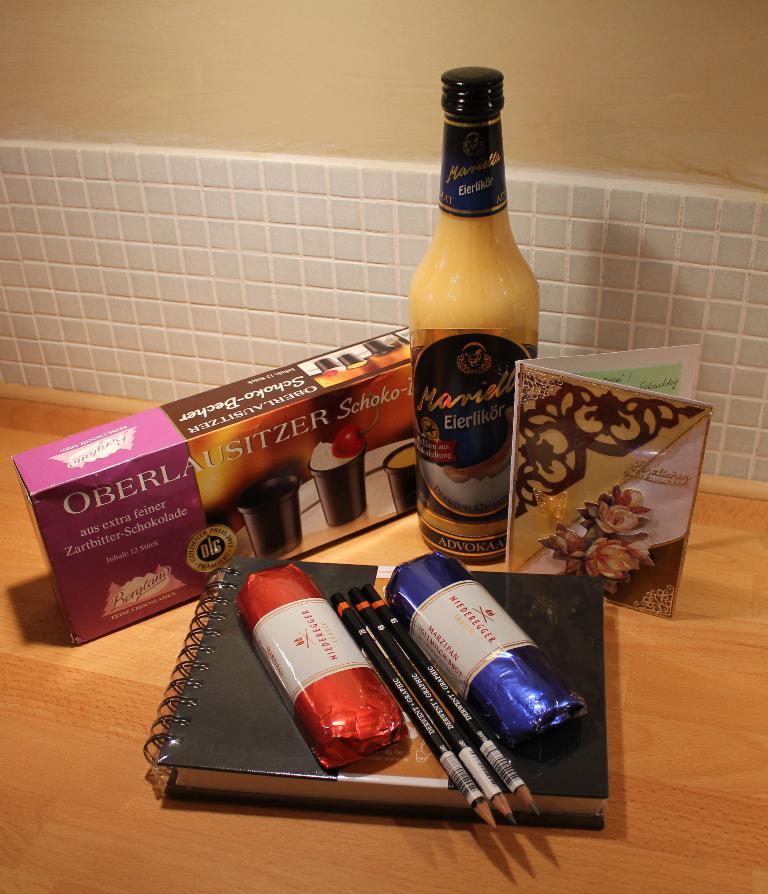How many pencils are on top of the black notebook?
Make the answer very short. 3. 